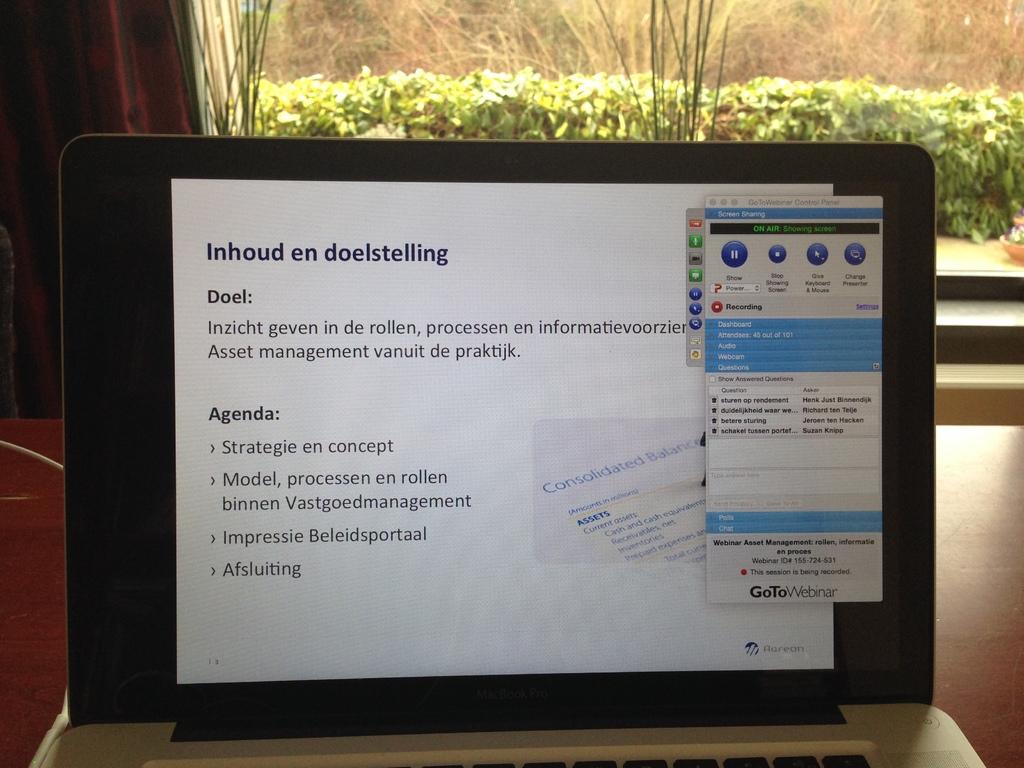What is the heading?
Keep it short and to the point. Inhoud en doelstelling. 